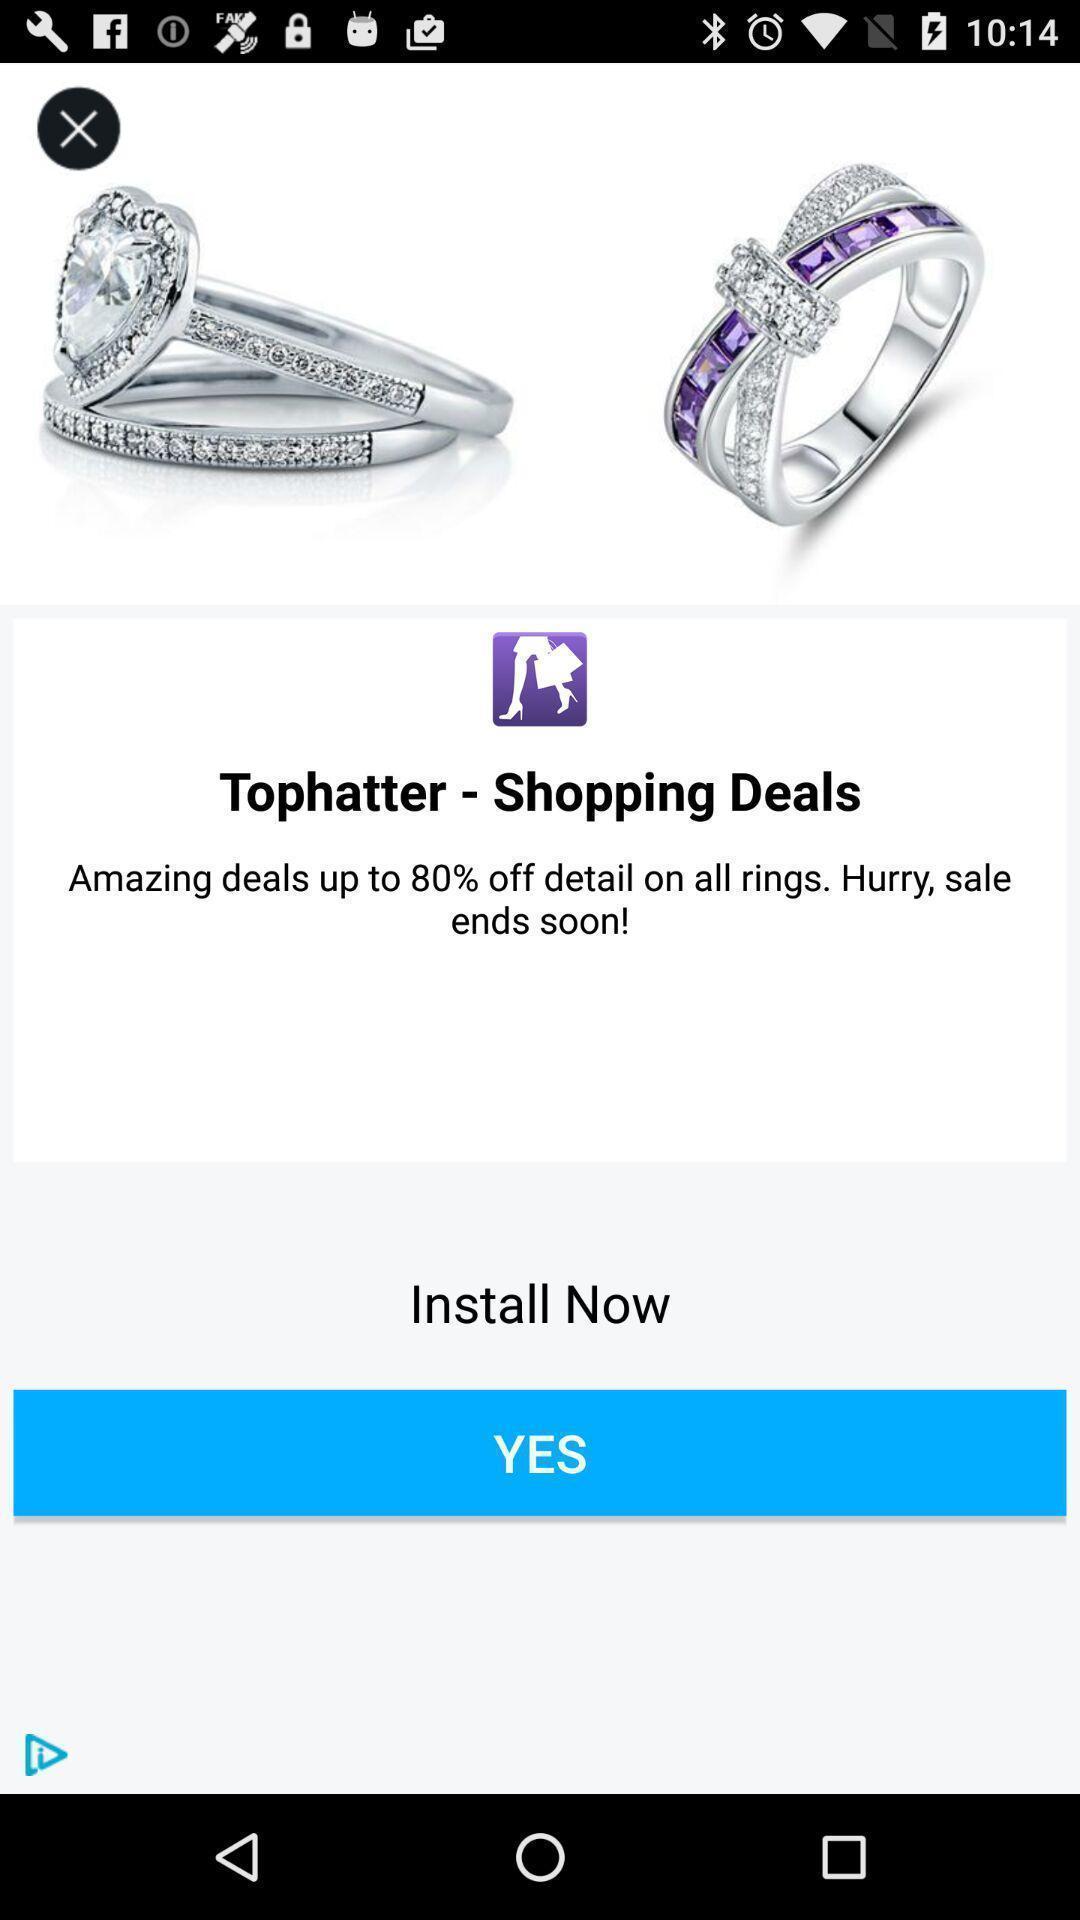Explain what's happening in this screen capture. Screen showing installation page of a shopping app. 